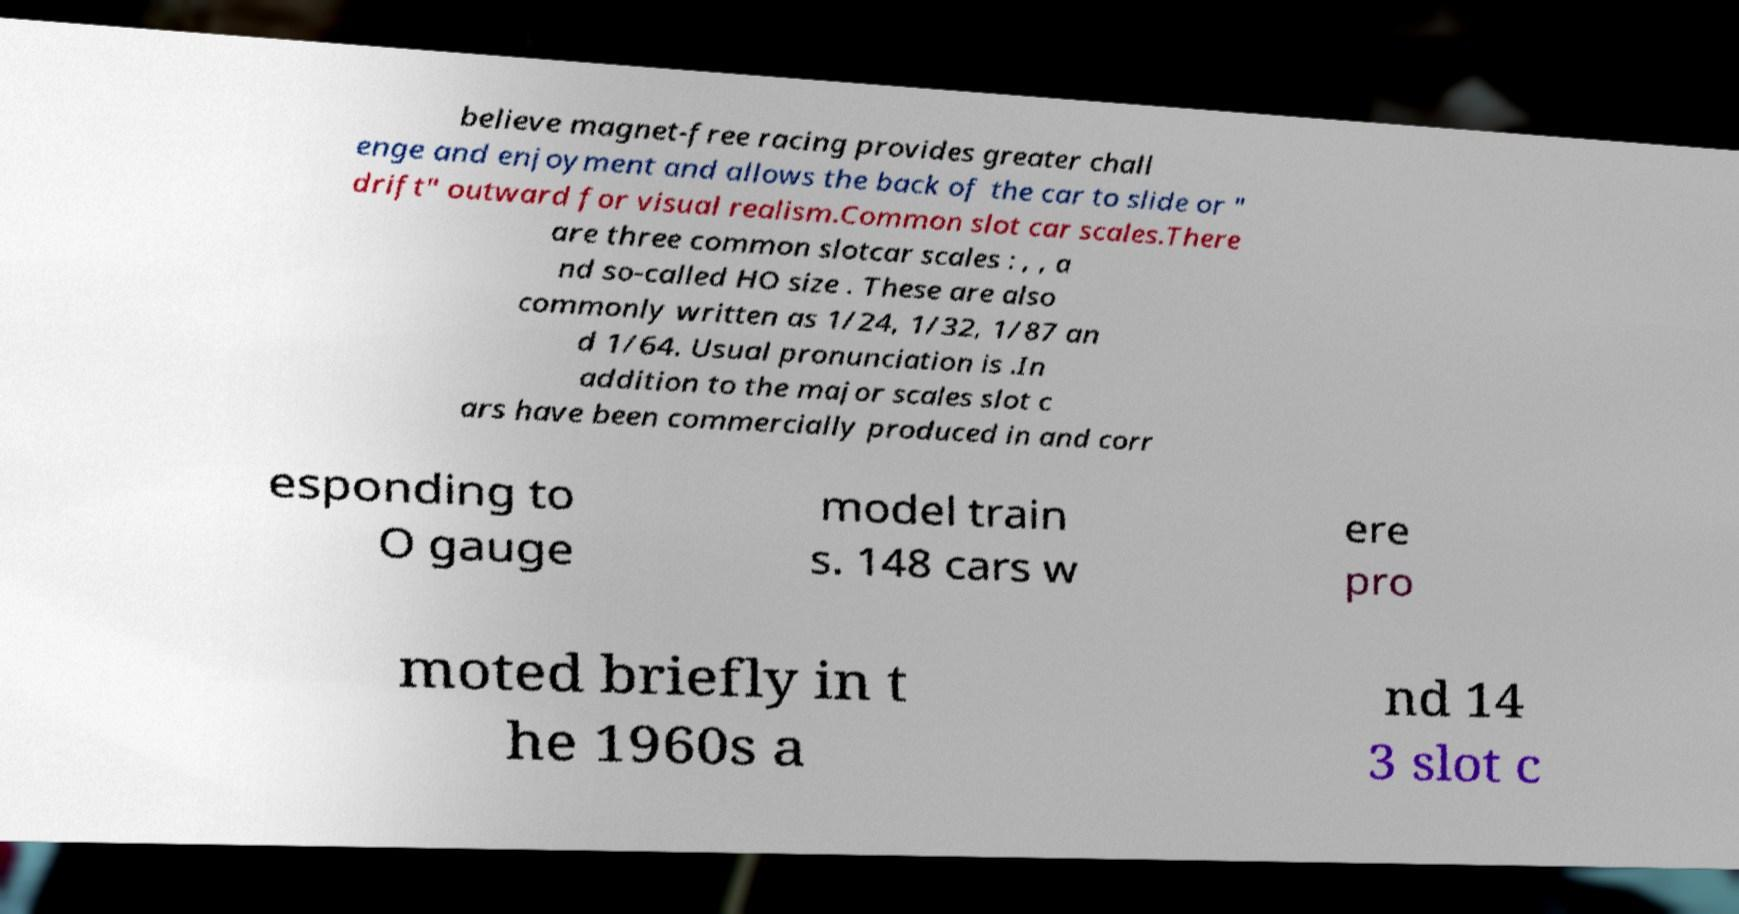Can you accurately transcribe the text from the provided image for me? believe magnet-free racing provides greater chall enge and enjoyment and allows the back of the car to slide or " drift" outward for visual realism.Common slot car scales.There are three common slotcar scales : , , a nd so-called HO size . These are also commonly written as 1/24, 1/32, 1/87 an d 1/64. Usual pronunciation is .In addition to the major scales slot c ars have been commercially produced in and corr esponding to O gauge model train s. 148 cars w ere pro moted briefly in t he 1960s a nd 14 3 slot c 